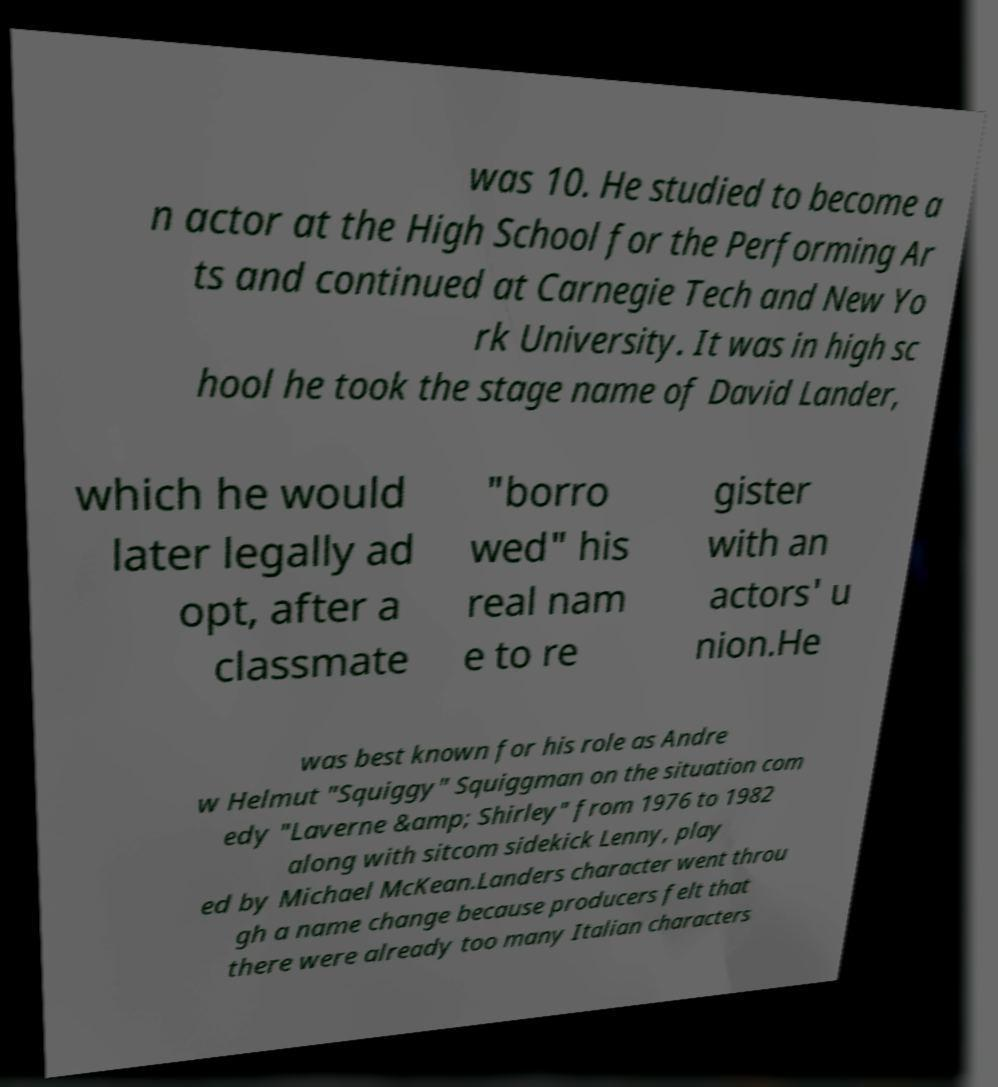Please identify and transcribe the text found in this image. was 10. He studied to become a n actor at the High School for the Performing Ar ts and continued at Carnegie Tech and New Yo rk University. It was in high sc hool he took the stage name of David Lander, which he would later legally ad opt, after a classmate "borro wed" his real nam e to re gister with an actors' u nion.He was best known for his role as Andre w Helmut "Squiggy" Squiggman on the situation com edy "Laverne &amp; Shirley" from 1976 to 1982 along with sitcom sidekick Lenny, play ed by Michael McKean.Landers character went throu gh a name change because producers felt that there were already too many Italian characters 